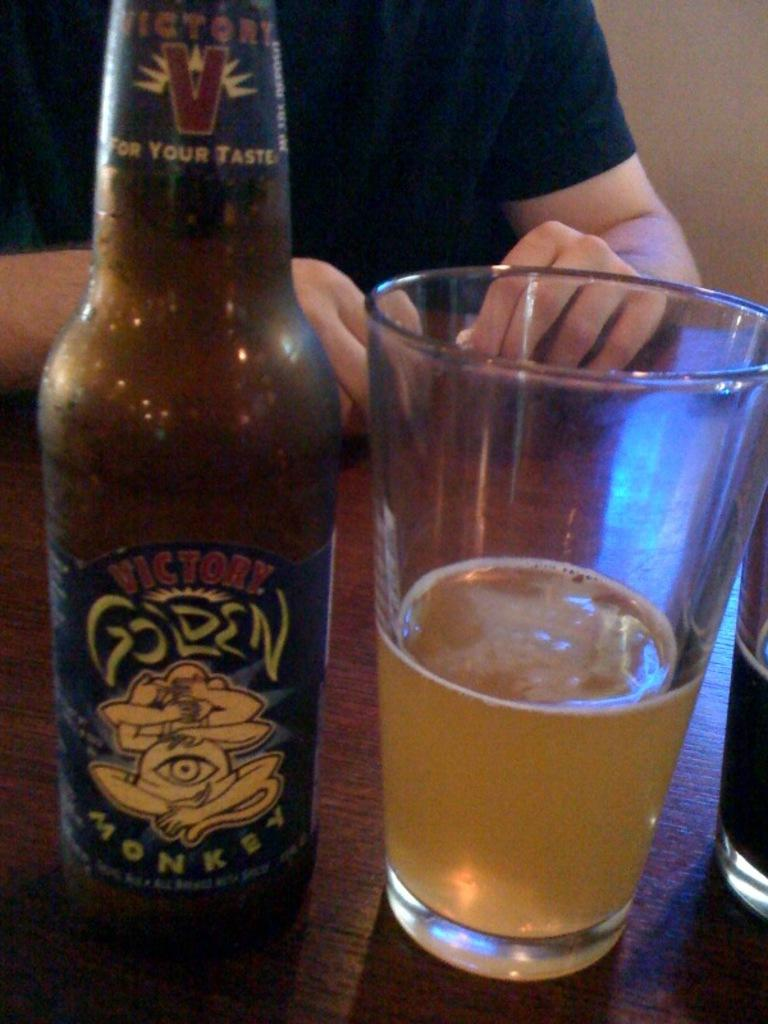<image>
Create a compact narrative representing the image presented. a bottle of victory golden monkey standing next to a glass filled with it 